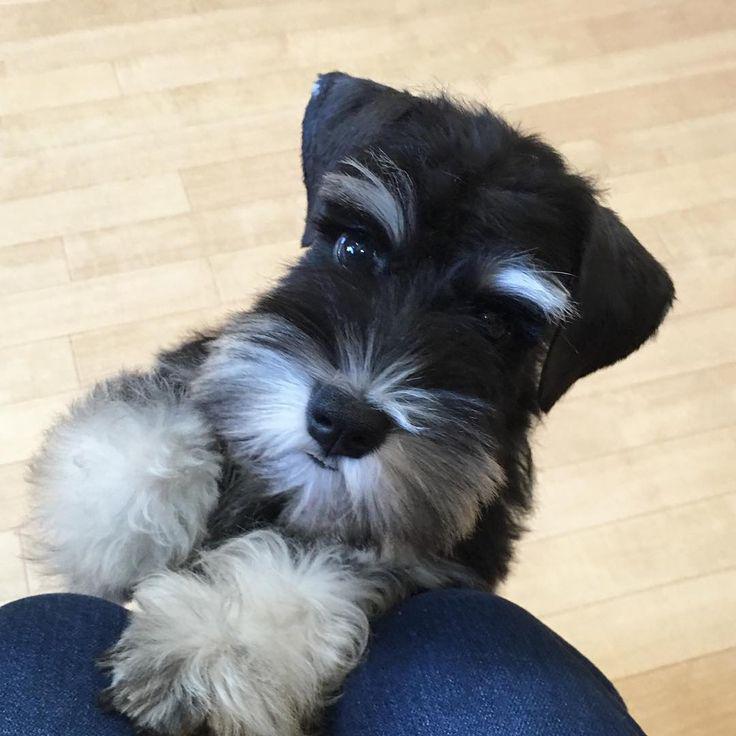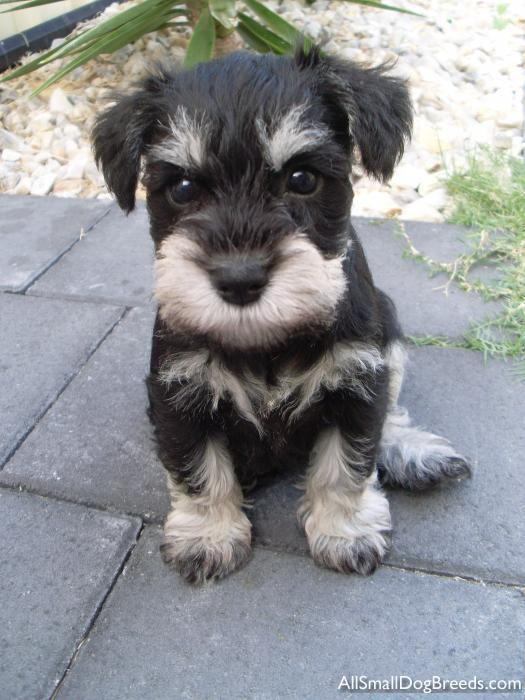The first image is the image on the left, the second image is the image on the right. Considering the images on both sides, is "The dog in the left photo is biting something." valid? Answer yes or no. No. The first image is the image on the left, the second image is the image on the right. Considering the images on both sides, is "In one image, a little dog with ears flopping forward has a blue toy at its front feet." valid? Answer yes or no. No. 